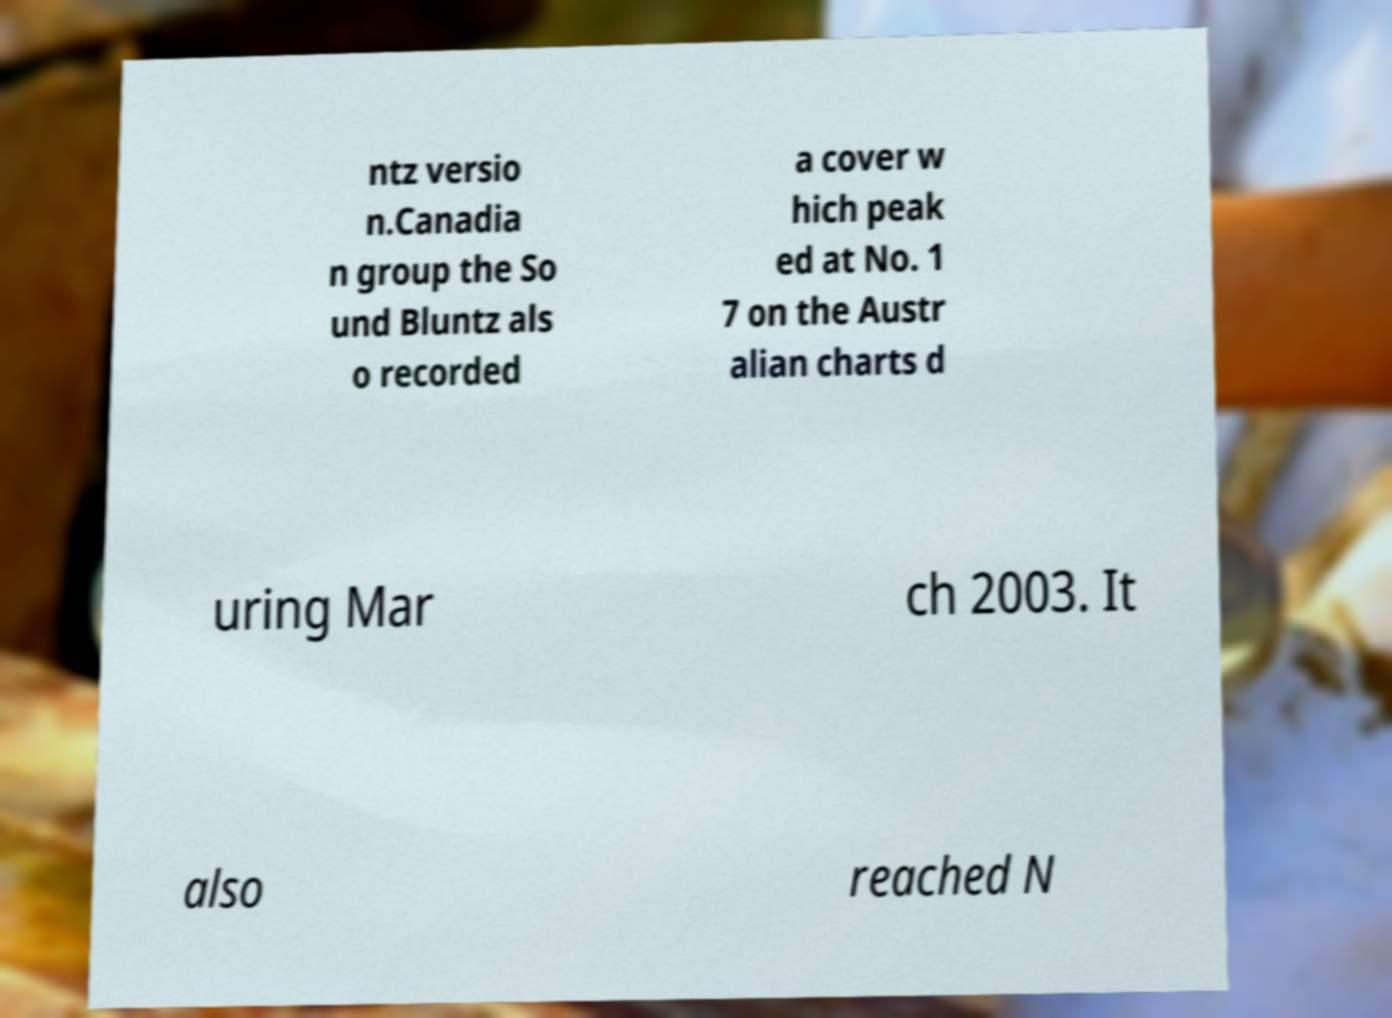There's text embedded in this image that I need extracted. Can you transcribe it verbatim? ntz versio n.Canadia n group the So und Bluntz als o recorded a cover w hich peak ed at No. 1 7 on the Austr alian charts d uring Mar ch 2003. It also reached N 